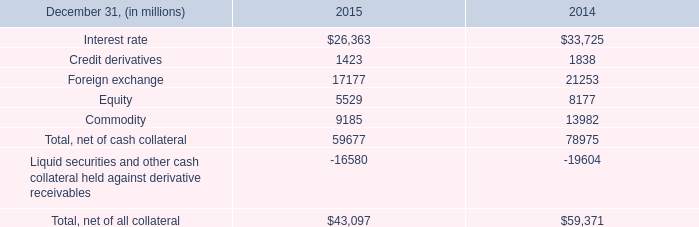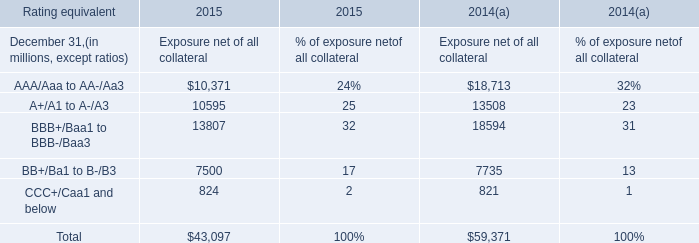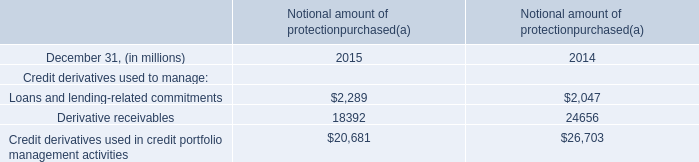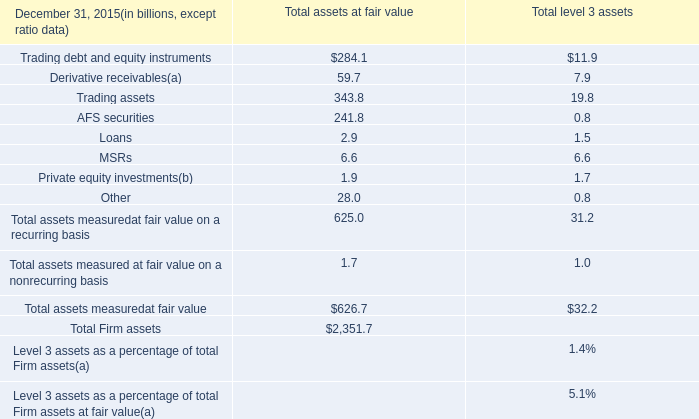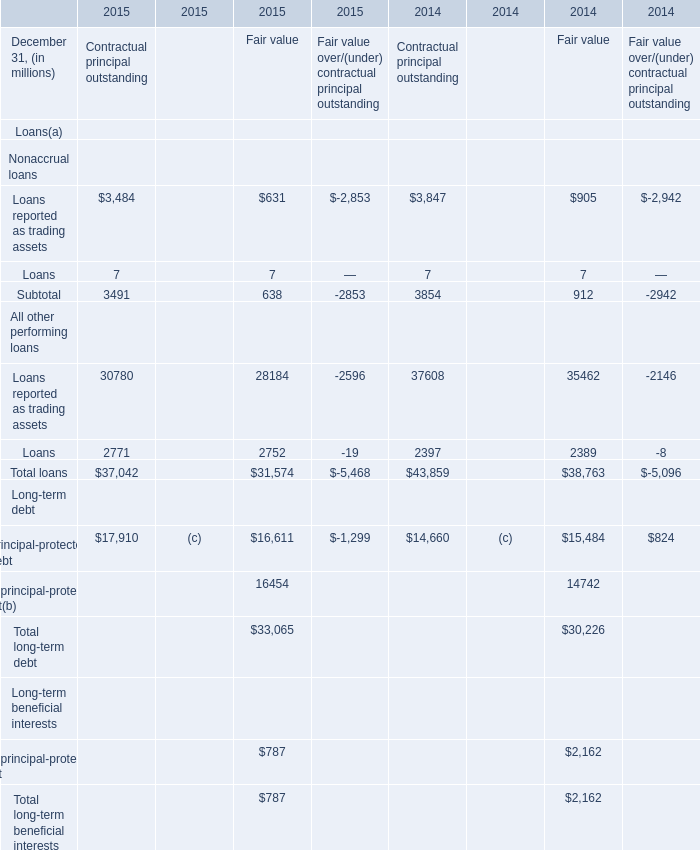what was the change in the derivative receivables reported on the consolidated balance sheets from 2014 to 2015 
Computations: (59.7 - 79.0)
Answer: -19.3. 